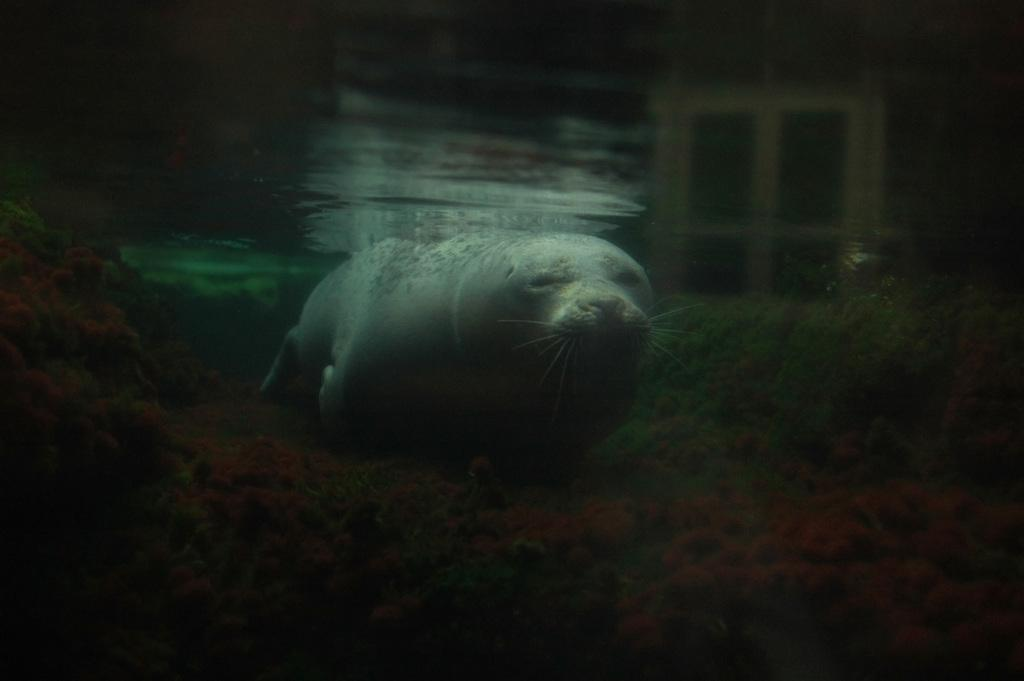What is the setting of the image? The image is taken underwater. What is the main subject of the image? There is an animal at the center of the image. Can you hear the animal laughing in the image? The image is silent, and there is no indication of laughter or any sound. Additionally, animals do not laugh like humans do. 